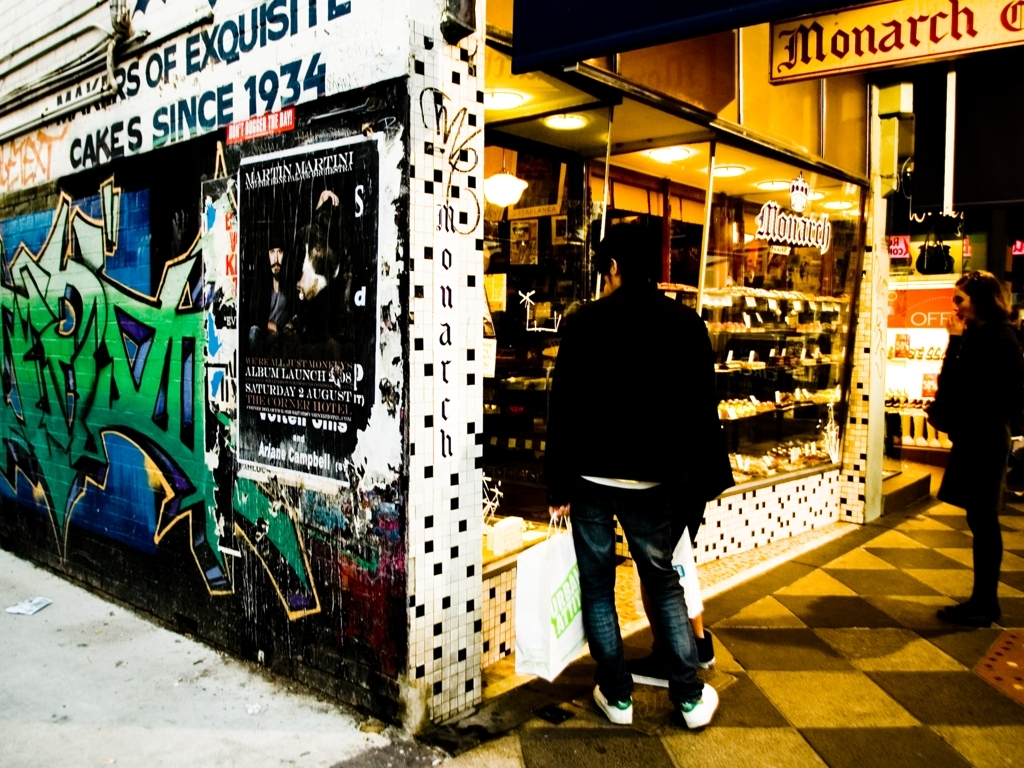What time of day does the scene depict, and how can you tell? The scene is likely set in the early evening, which can be surmised from the artificial lighting in the shop spilling out onto the sidewalk, coupled with the residual natural light fading from the sky. The shadows are elongated but still distinct, suggesting the sun has just set. 